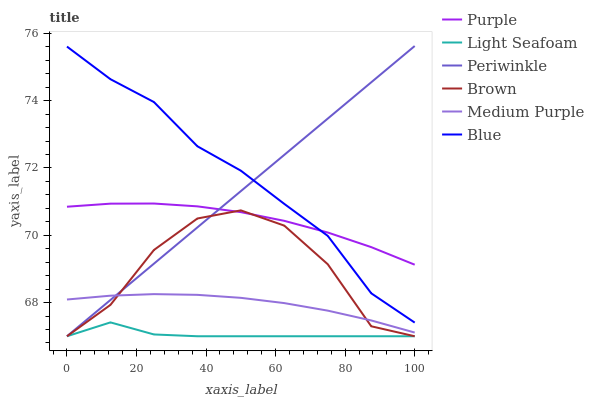Does Light Seafoam have the minimum area under the curve?
Answer yes or no. Yes. Does Blue have the maximum area under the curve?
Answer yes or no. Yes. Does Brown have the minimum area under the curve?
Answer yes or no. No. Does Brown have the maximum area under the curve?
Answer yes or no. No. Is Periwinkle the smoothest?
Answer yes or no. Yes. Is Brown the roughest?
Answer yes or no. Yes. Is Purple the smoothest?
Answer yes or no. No. Is Purple the roughest?
Answer yes or no. No. Does Brown have the lowest value?
Answer yes or no. Yes. Does Purple have the lowest value?
Answer yes or no. No. Does Periwinkle have the highest value?
Answer yes or no. Yes. Does Brown have the highest value?
Answer yes or no. No. Is Light Seafoam less than Purple?
Answer yes or no. Yes. Is Medium Purple greater than Light Seafoam?
Answer yes or no. Yes. Does Periwinkle intersect Purple?
Answer yes or no. Yes. Is Periwinkle less than Purple?
Answer yes or no. No. Is Periwinkle greater than Purple?
Answer yes or no. No. Does Light Seafoam intersect Purple?
Answer yes or no. No. 